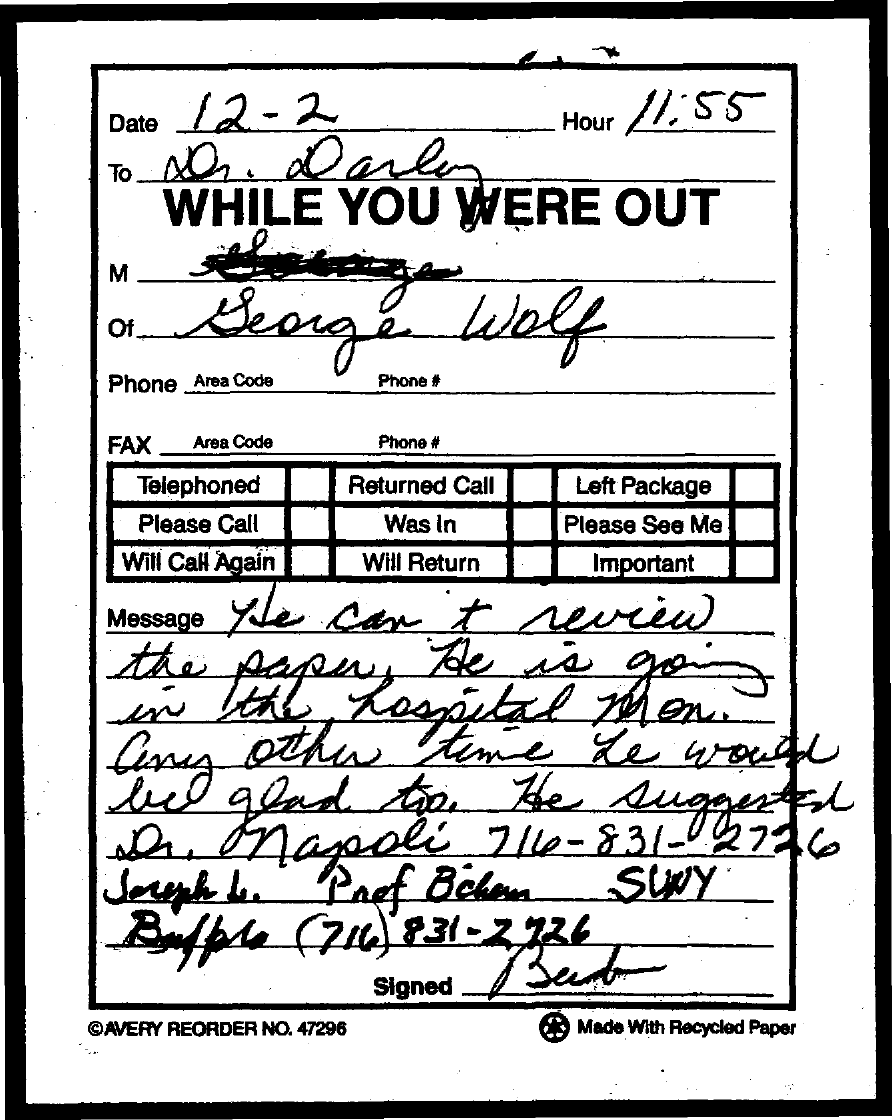What is the Hour/time mentioned in the document?
Make the answer very short. 11:55. 